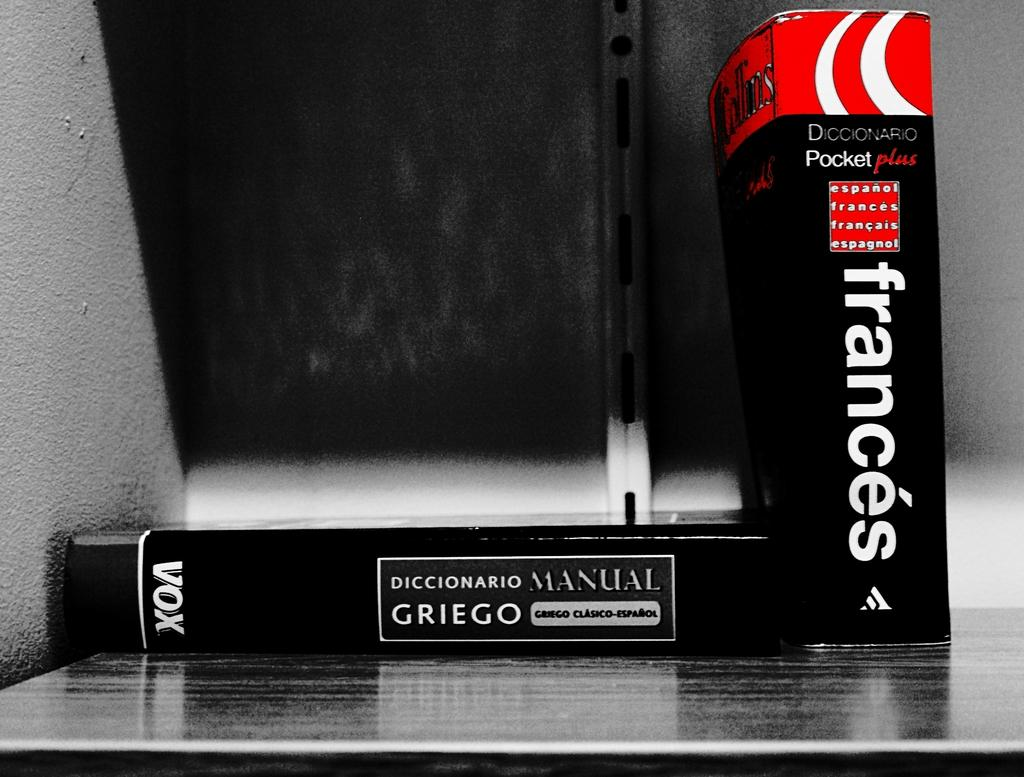<image>
Summarize the visual content of the image. Two black books laying on a table with Diccianaro Manual written on one and Frances written on the other. 